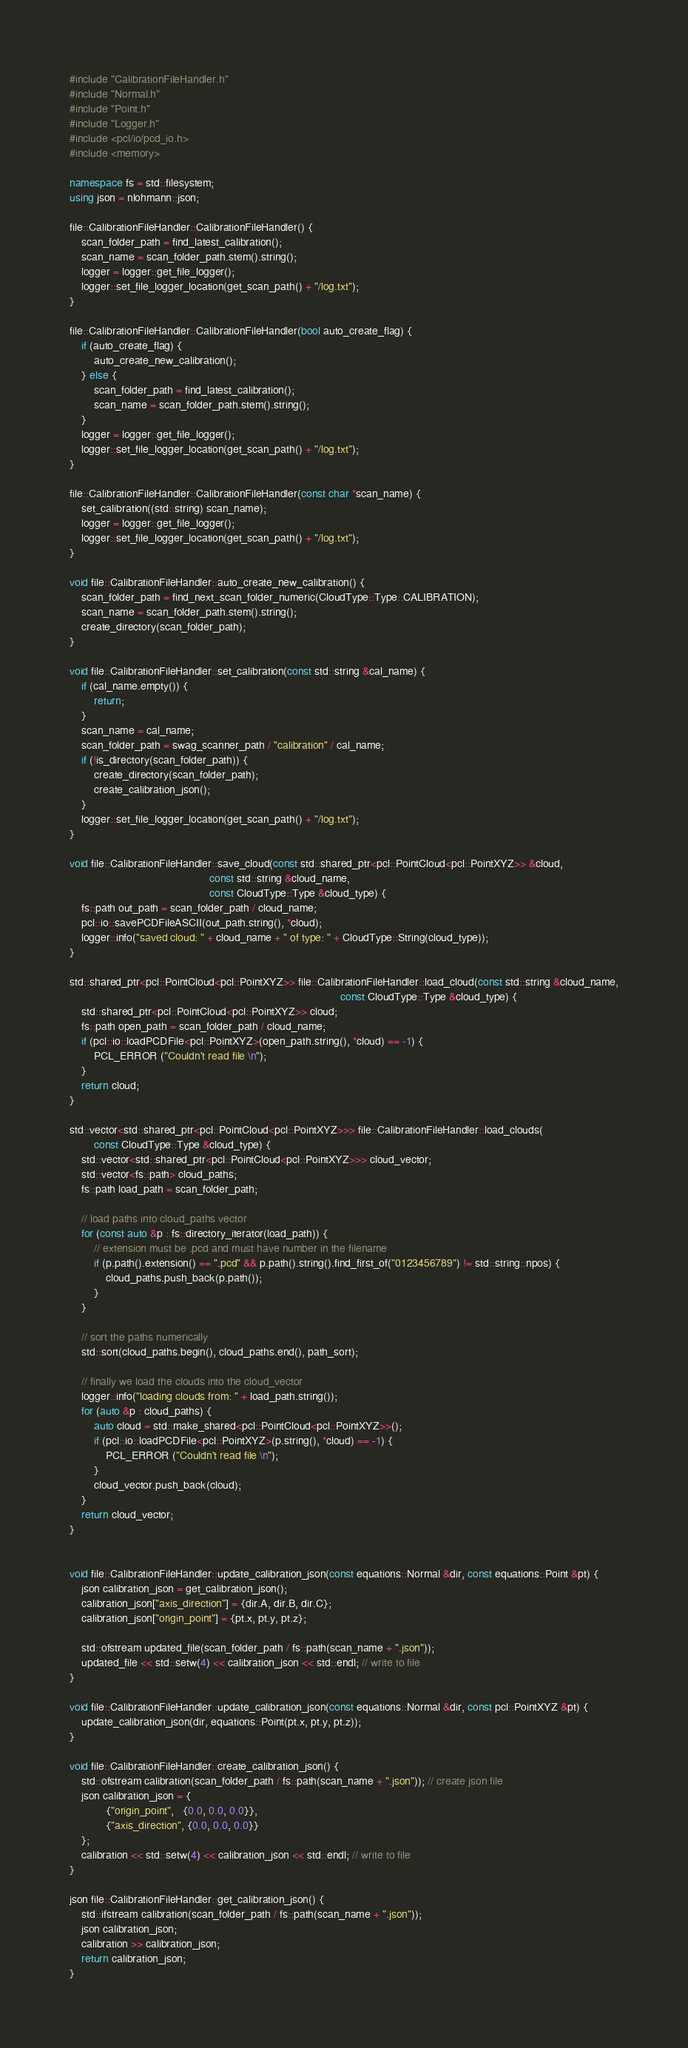<code> <loc_0><loc_0><loc_500><loc_500><_C++_>#include "CalibrationFileHandler.h"
#include "Normal.h"
#include "Point.h"
#include "Logger.h"
#include <pcl/io/pcd_io.h>
#include <memory>

namespace fs = std::filesystem;
using json = nlohmann::json;

file::CalibrationFileHandler::CalibrationFileHandler() {
    scan_folder_path = find_latest_calibration();
    scan_name = scan_folder_path.stem().string();
    logger = logger::get_file_logger();
    logger::set_file_logger_location(get_scan_path() + "/log.txt");
}

file::CalibrationFileHandler::CalibrationFileHandler(bool auto_create_flag) {
    if (auto_create_flag) {
        auto_create_new_calibration();
    } else {
        scan_folder_path = find_latest_calibration();
        scan_name = scan_folder_path.stem().string();
    }
    logger = logger::get_file_logger();
    logger::set_file_logger_location(get_scan_path() + "/log.txt");
}

file::CalibrationFileHandler::CalibrationFileHandler(const char *scan_name) {
    set_calibration((std::string) scan_name);
    logger = logger::get_file_logger();
    logger::set_file_logger_location(get_scan_path() + "/log.txt");
}

void file::CalibrationFileHandler::auto_create_new_calibration() {
    scan_folder_path = find_next_scan_folder_numeric(CloudType::Type::CALIBRATION);
    scan_name = scan_folder_path.stem().string();
    create_directory(scan_folder_path);
}

void file::CalibrationFileHandler::set_calibration(const std::string &cal_name) {
    if (cal_name.empty()) {
        return;
    }
    scan_name = cal_name;
    scan_folder_path = swag_scanner_path / "calibration" / cal_name;
    if (!is_directory(scan_folder_path)) {
        create_directory(scan_folder_path);
        create_calibration_json();
    }
    logger::set_file_logger_location(get_scan_path() + "/log.txt");
}

void file::CalibrationFileHandler::save_cloud(const std::shared_ptr<pcl::PointCloud<pcl::PointXYZ>> &cloud,
                                              const std::string &cloud_name,
                                              const CloudType::Type &cloud_type) {
    fs::path out_path = scan_folder_path / cloud_name;
    pcl::io::savePCDFileASCII(out_path.string(), *cloud);
    logger::info("saved cloud: " + cloud_name + " of type: " + CloudType::String(cloud_type));
}

std::shared_ptr<pcl::PointCloud<pcl::PointXYZ>> file::CalibrationFileHandler::load_cloud(const std::string &cloud_name,
                                                                                         const CloudType::Type &cloud_type) {
    std::shared_ptr<pcl::PointCloud<pcl::PointXYZ>> cloud;
    fs::path open_path = scan_folder_path / cloud_name;
    if (pcl::io::loadPCDFile<pcl::PointXYZ>(open_path.string(), *cloud) == -1) {
        PCL_ERROR ("Couldn't read file \n");
    }
    return cloud;
}

std::vector<std::shared_ptr<pcl::PointCloud<pcl::PointXYZ>>> file::CalibrationFileHandler::load_clouds(
        const CloudType::Type &cloud_type) {
    std::vector<std::shared_ptr<pcl::PointCloud<pcl::PointXYZ>>> cloud_vector;
    std::vector<fs::path> cloud_paths;
    fs::path load_path = scan_folder_path;

    // load paths into cloud_paths vector
    for (const auto &p : fs::directory_iterator(load_path)) {
        // extension must be .pcd and must have number in the filename
        if (p.path().extension() == ".pcd" && p.path().string().find_first_of("0123456789") != std::string::npos) {
            cloud_paths.push_back(p.path());
        }
    }

    // sort the paths numerically
    std::sort(cloud_paths.begin(), cloud_paths.end(), path_sort);

    // finally we load the clouds into the cloud_vector
    logger::info("loading clouds from: " + load_path.string());
    for (auto &p : cloud_paths) {
        auto cloud = std::make_shared<pcl::PointCloud<pcl::PointXYZ>>();
        if (pcl::io::loadPCDFile<pcl::PointXYZ>(p.string(), *cloud) == -1) {
            PCL_ERROR ("Couldn't read file \n");
        }
        cloud_vector.push_back(cloud);
    }
    return cloud_vector;
}


void file::CalibrationFileHandler::update_calibration_json(const equations::Normal &dir, const equations::Point &pt) {
    json calibration_json = get_calibration_json();
    calibration_json["axis_direction"] = {dir.A, dir.B, dir.C};
    calibration_json["origin_point"] = {pt.x, pt.y, pt.z};

    std::ofstream updated_file(scan_folder_path / fs::path(scan_name + ".json"));
    updated_file << std::setw(4) << calibration_json << std::endl; // write to file
}

void file::CalibrationFileHandler::update_calibration_json(const equations::Normal &dir, const pcl::PointXYZ &pt) {
    update_calibration_json(dir, equations::Point(pt.x, pt.y, pt.z));
}

void file::CalibrationFileHandler::create_calibration_json() {
    std::ofstream calibration(scan_folder_path / fs::path(scan_name + ".json")); // create json file
    json calibration_json = {
            {"origin_point",   {0.0, 0.0, 0.0}},
            {"axis_direction", {0.0, 0.0, 0.0}}
    };
    calibration << std::setw(4) << calibration_json << std::endl; // write to file
}

json file::CalibrationFileHandler::get_calibration_json() {
    std::ifstream calibration(scan_folder_path / fs::path(scan_name + ".json"));
    json calibration_json;
    calibration >> calibration_json;
    return calibration_json;
}


</code> 